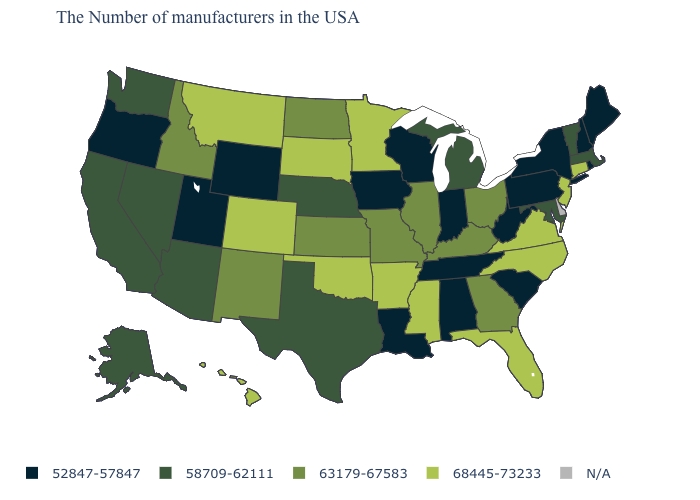What is the value of Delaware?
Write a very short answer. N/A. Among the states that border Arkansas , which have the lowest value?
Quick response, please. Tennessee, Louisiana. Which states have the highest value in the USA?
Concise answer only. Connecticut, New Jersey, Virginia, North Carolina, Florida, Mississippi, Arkansas, Minnesota, Oklahoma, South Dakota, Colorado, Montana, Hawaii. What is the value of Ohio?
Give a very brief answer. 63179-67583. Does the map have missing data?
Write a very short answer. Yes. Name the states that have a value in the range 68445-73233?
Be succinct. Connecticut, New Jersey, Virginia, North Carolina, Florida, Mississippi, Arkansas, Minnesota, Oklahoma, South Dakota, Colorado, Montana, Hawaii. Is the legend a continuous bar?
Write a very short answer. No. What is the value of Alaska?
Concise answer only. 58709-62111. Which states have the lowest value in the MidWest?
Answer briefly. Indiana, Wisconsin, Iowa. What is the lowest value in the MidWest?
Short answer required. 52847-57847. Which states hav the highest value in the Northeast?
Keep it brief. Connecticut, New Jersey. Does Pennsylvania have the lowest value in the Northeast?
Concise answer only. Yes. What is the highest value in the West ?
Concise answer only. 68445-73233. Among the states that border Alabama , which have the highest value?
Give a very brief answer. Florida, Mississippi. Name the states that have a value in the range 68445-73233?
Be succinct. Connecticut, New Jersey, Virginia, North Carolina, Florida, Mississippi, Arkansas, Minnesota, Oklahoma, South Dakota, Colorado, Montana, Hawaii. 